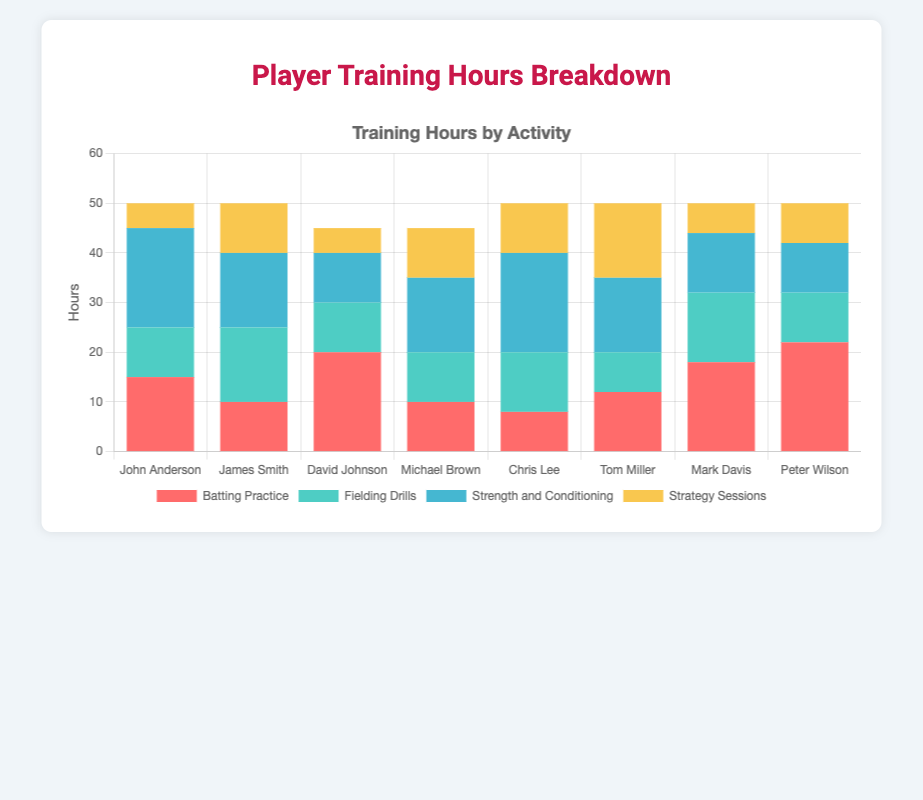Which player spent the most hours in batting practice? To find the player who spent the most hours in batting practice, look at the "Batting Practice" data series and identify the highest value. Peter Wilson has the highest value of 22 hours.
Answer: Peter Wilson Compare the total training hours between John Anderson and James Smith. Who trained more and by how much? To compare the total training hours, sum up all training activities for each player. John Anderson: 15 + 10 + 20 + 5 = 50 hours. James Smith: 10 + 15 + 15 + 10 = 50 hours. Both trained the same amount.
Answer: Both trained the same Which player dedicated the least hours to strategy sessions, and how many hours did they spend? Identify the lowest value in the "Strategy Sessions" data series. John Anderson and David Johnson both spent 5 hours, the least amount.
Answer: John Anderson and David Johnson, 5 hours What is the average amount of time spent on fielding drills by all players? First, sum the hours spent on fielding drills by all players: 10 + 15 + 10 + 10 + 12 + 8 + 14 + 10 = 89. Then, divide by the number of players (8). 89 / 8 = 11.125.
Answer: 11.125 Which two players have identical hours for strength and conditioning, and what are those hours? Look at the "Strength and Conditioning" data series and find identical values. James Smith and Michael Brown both spent 15 hours.
Answer: James Smith and Michael Brown, 15 hours Rank the players based on their total training hours in descending order. Sum the total training hours for each player and then sort them:
Peter Wilson: 50
Mark Davis: 50
John Anderson: 50
James Smith: 50
Chris Lee: 50
Tom Miller: 50
Michael Brown: 45
David Johnson: 45.
Answer: Peter Wilson, Mark Davis, John Anderson, James Smith, Chris Lee, Tom Miller, Michael Brown, David Johnson Which training activity has the highest total hours across all players, and how many hours is it? Sum the hours for each training activity across all players and compare:
Batting Practice: 115
Fielding Drills: 89
Strength and Conditioning: 117
Strategy Sessions: 69
Strength and Conditioning has the highest total hours.
Answer: Strength and Conditioning, 117 hours Who spent the least amount of time on batting practice, and how many hours? Find the lowest value in the "Batting Practice" series. Chris Lee spent 8 hours, the least amount.
Answer: Chris Lee, 8 hours 